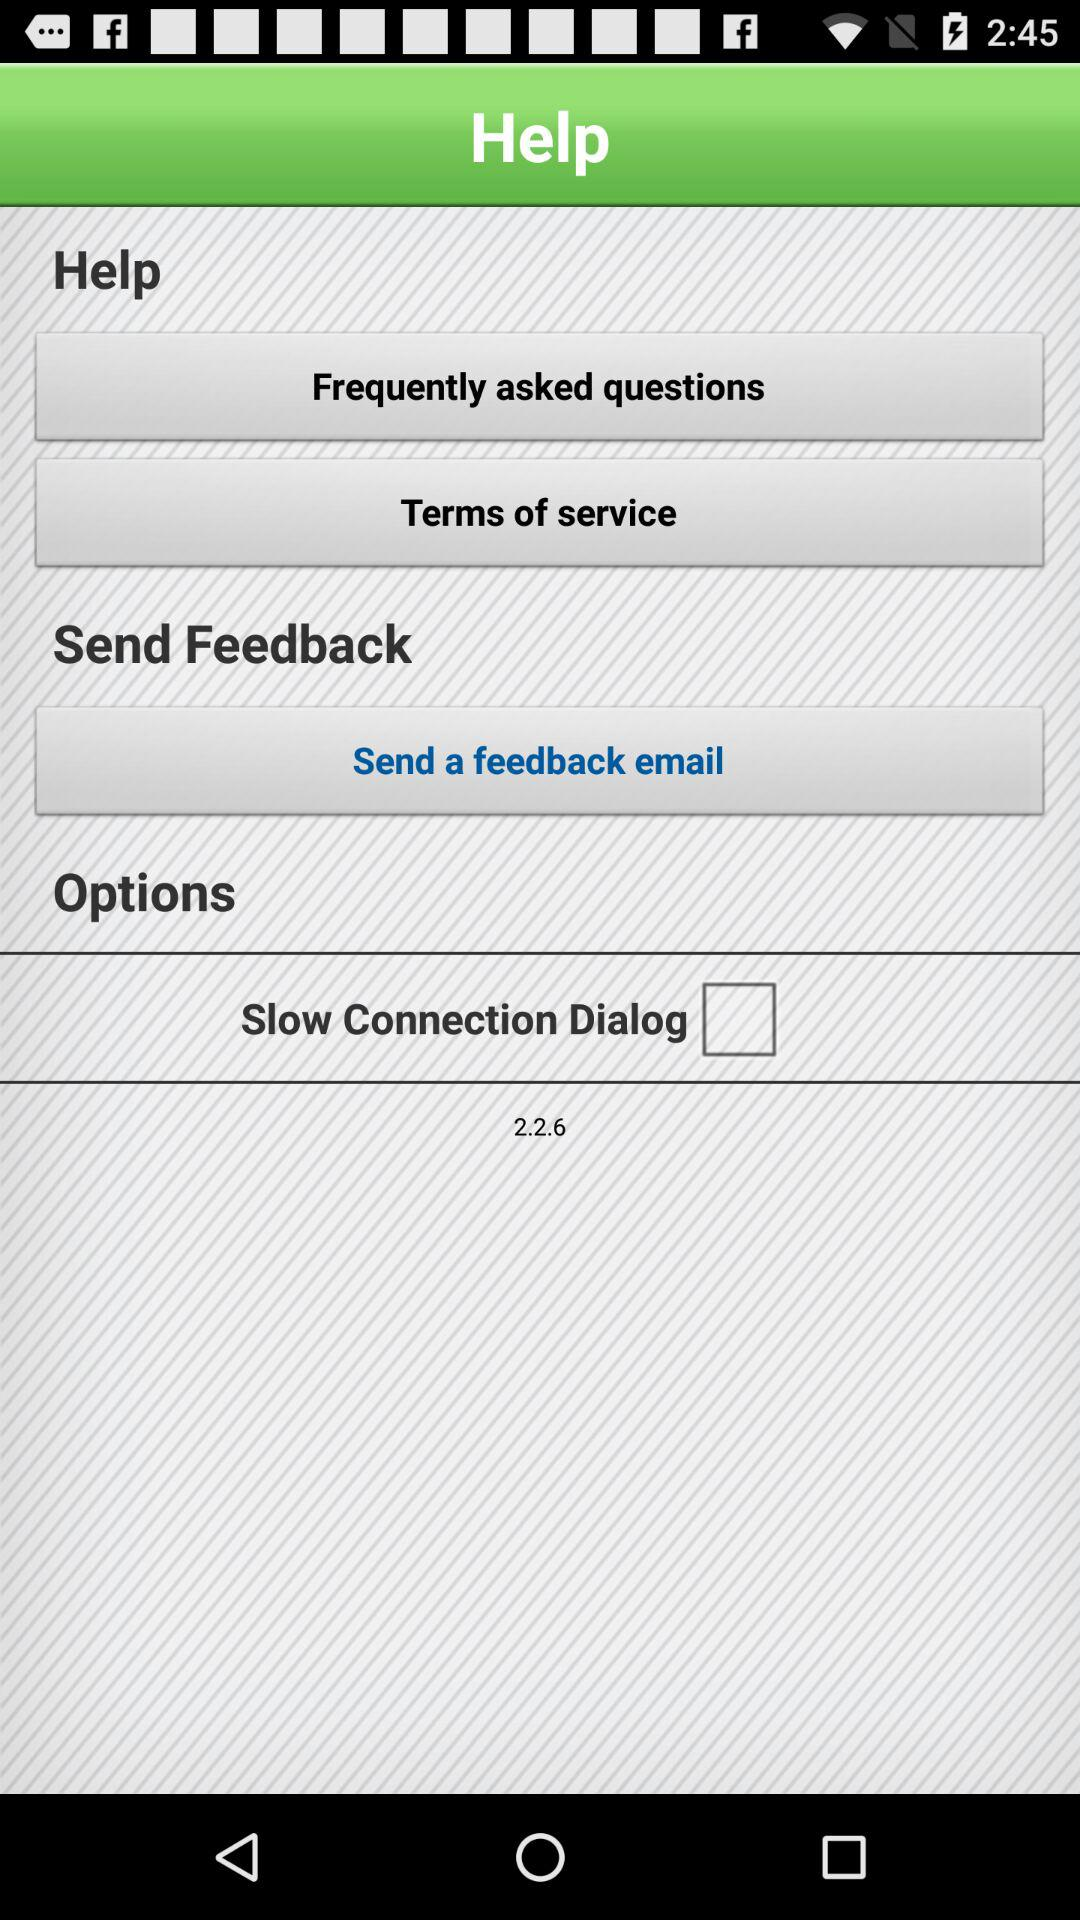What is the status of the "Slow Connection Dialog"? The status is "off". 